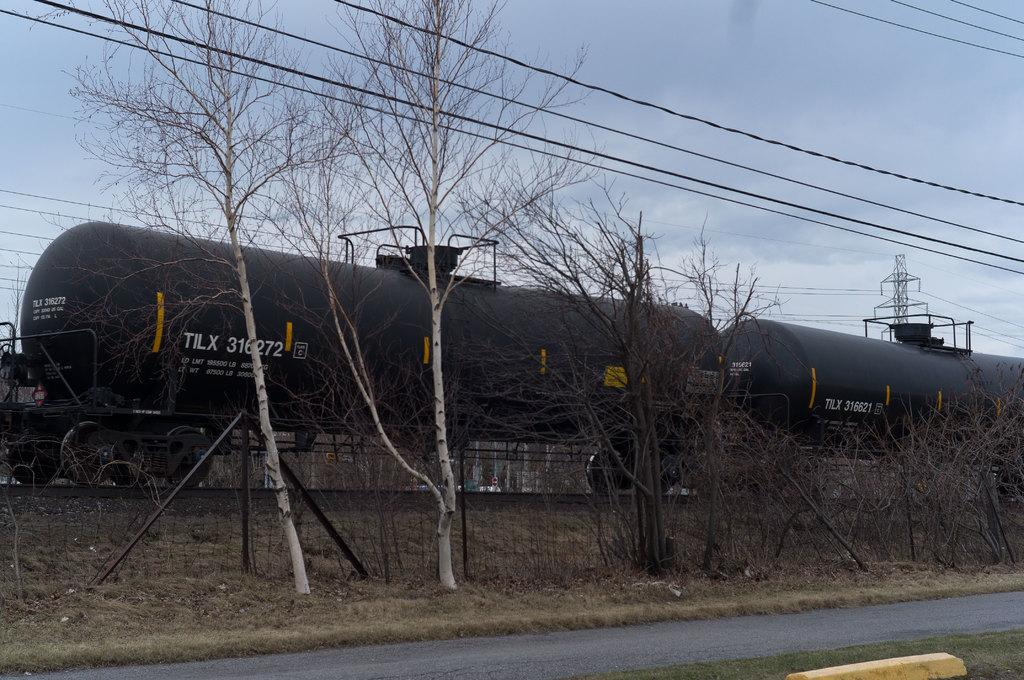What type of vegetation can be seen in the image? There are dried trees in the image. What can be seen in the background of the image? There is fencing visible in the background of the image. What mode of transportation is present in the image? There is a train on the track in the image. What else is present in the image besides the train and trees? There are wires in the image. How would you describe the color of the sky in the image? The sky is a combination of white and blue colors. Where is the store located in the image? There is no store present in the image. Can you describe the sponge that is being used to clean the train in the image? There is no sponge visible in the image, and the train is not being cleaned. 